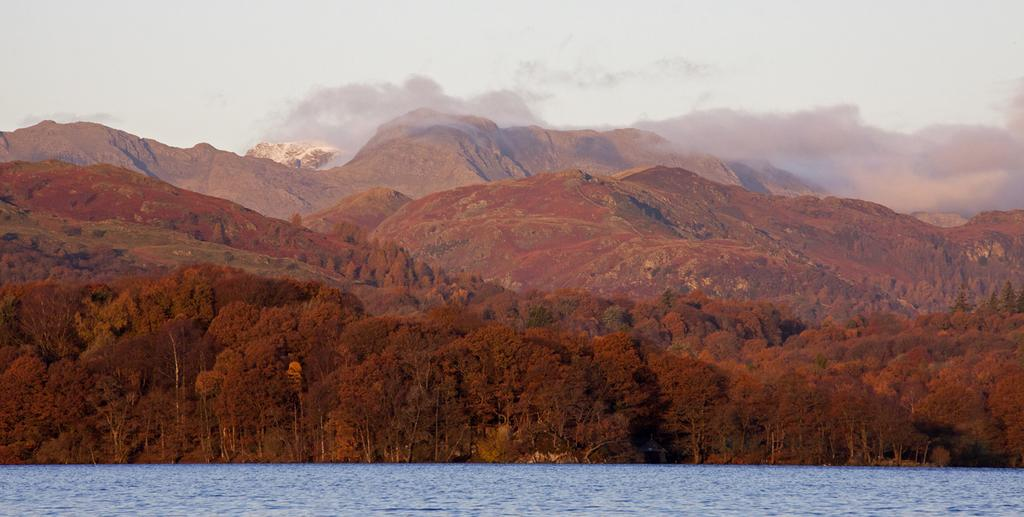What is present at the bottom of the image? There is water at the bottom of the image. What can be seen in the distance in the image? There are hills and trees in the background of the image. What is visible at the top of the image? The sky is visible at the top of the image. What type of hair can be seen on the trees in the image? There is no hair present on the trees in the image; they are covered with leaves and branches. What kind of attraction is visible in the image? There is no attraction present in the image; it features water, hills, trees, and the sky. 